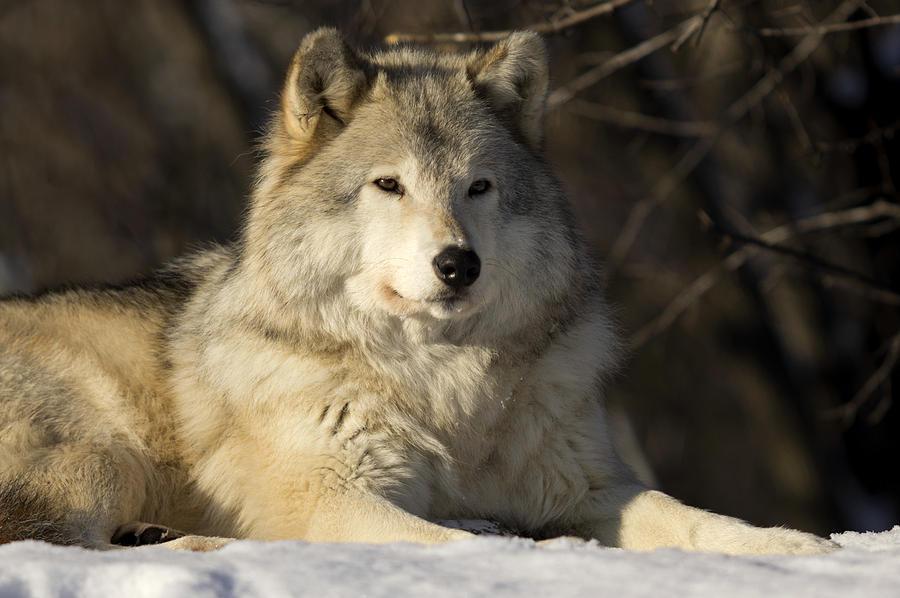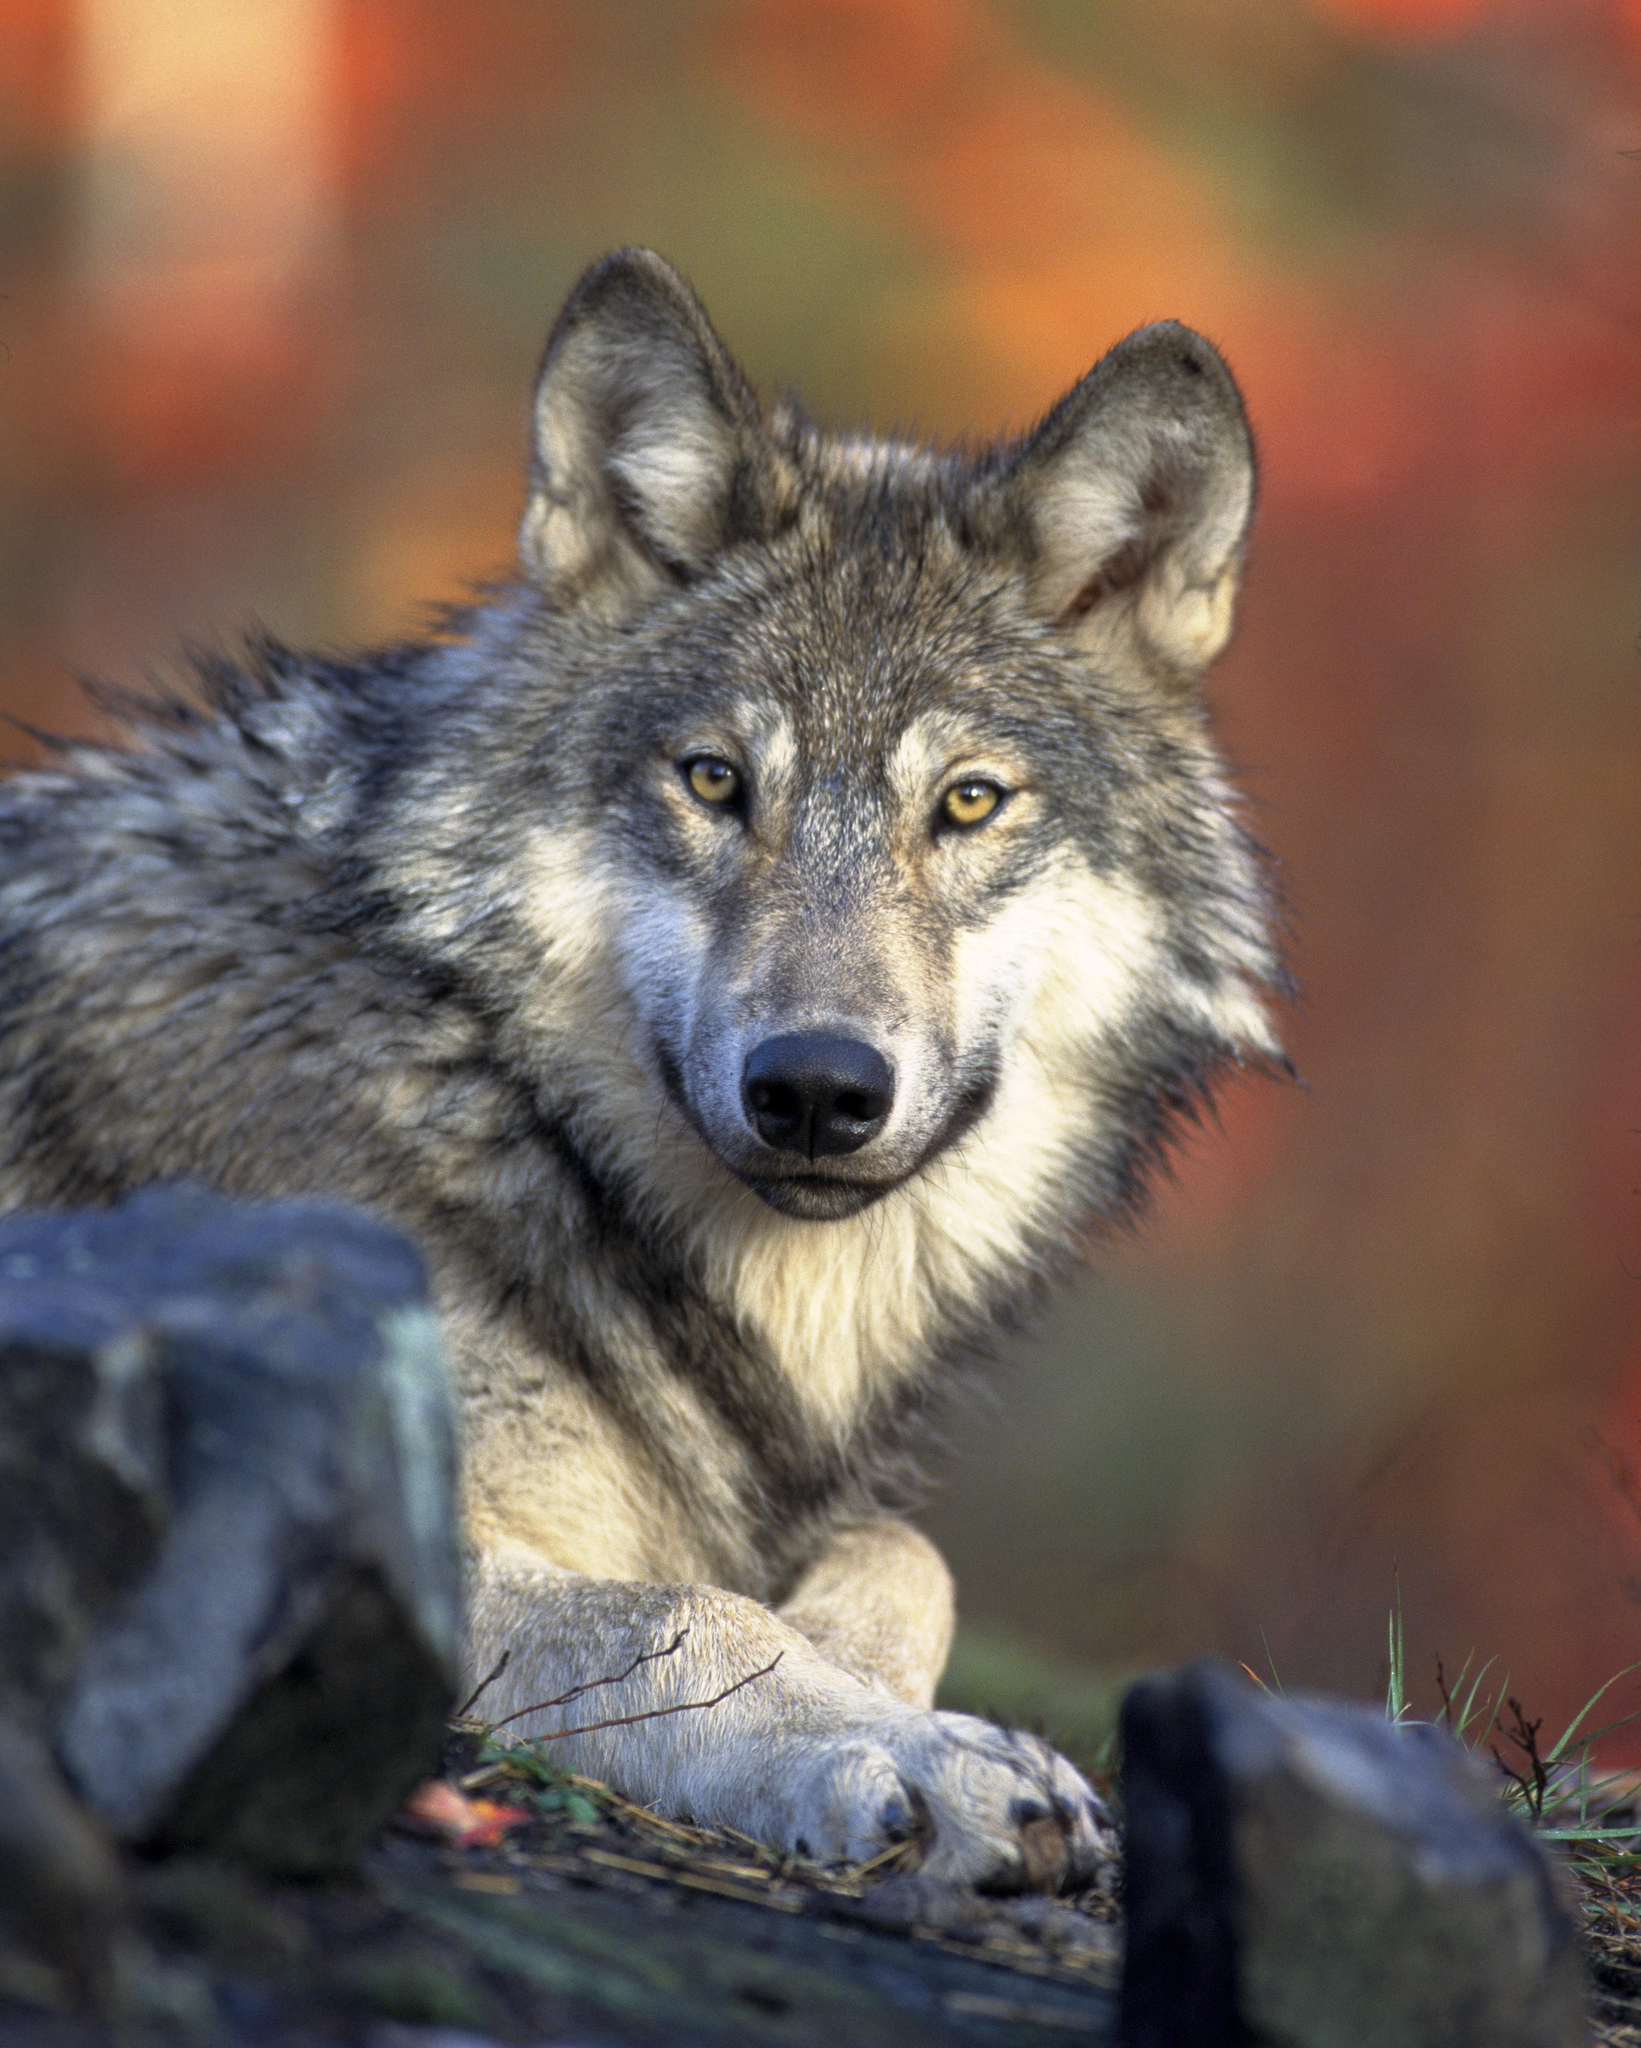The first image is the image on the left, the second image is the image on the right. For the images shown, is this caption "In each image the terrain around the wolf is covered in snow." true? Answer yes or no. No. The first image is the image on the left, the second image is the image on the right. Assess this claim about the two images: "Each image contains a single wolf, and the left image features a wolf reclining on the snow with its body angled rightward.". Correct or not? Answer yes or no. Yes. 